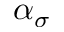<formula> <loc_0><loc_0><loc_500><loc_500>\alpha _ { \sigma }</formula> 